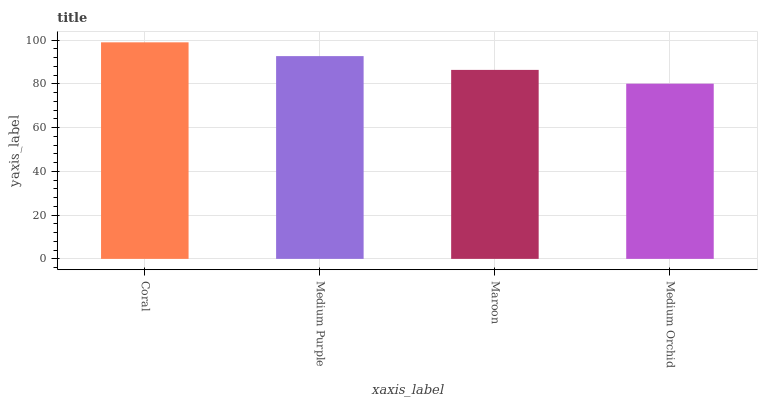Is Medium Purple the minimum?
Answer yes or no. No. Is Medium Purple the maximum?
Answer yes or no. No. Is Coral greater than Medium Purple?
Answer yes or no. Yes. Is Medium Purple less than Coral?
Answer yes or no. Yes. Is Medium Purple greater than Coral?
Answer yes or no. No. Is Coral less than Medium Purple?
Answer yes or no. No. Is Medium Purple the high median?
Answer yes or no. Yes. Is Maroon the low median?
Answer yes or no. Yes. Is Medium Orchid the high median?
Answer yes or no. No. Is Coral the low median?
Answer yes or no. No. 